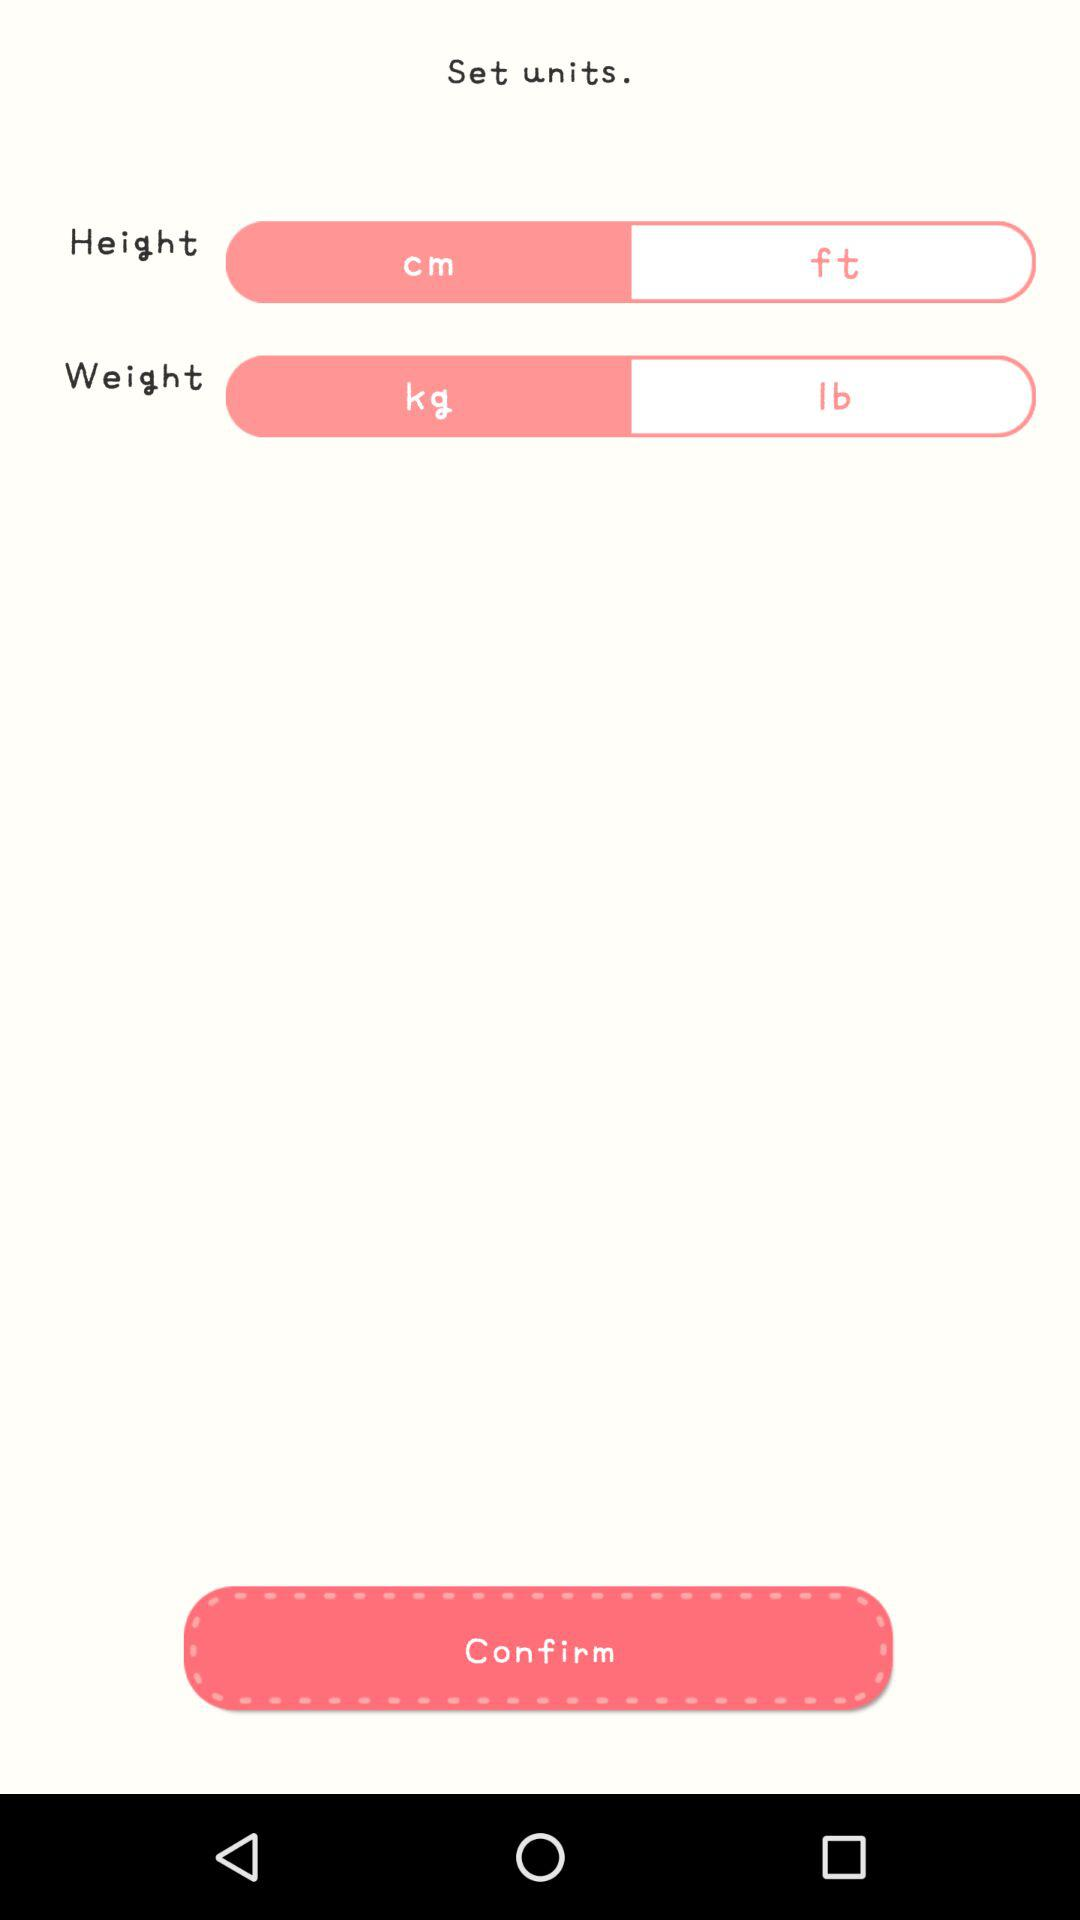What are the units of weight? The units of weight are kg and lb. 